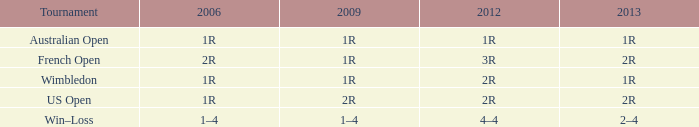What shows for 2013 when the 2012 is 2r, and a 2009 is 2r? 2R. 